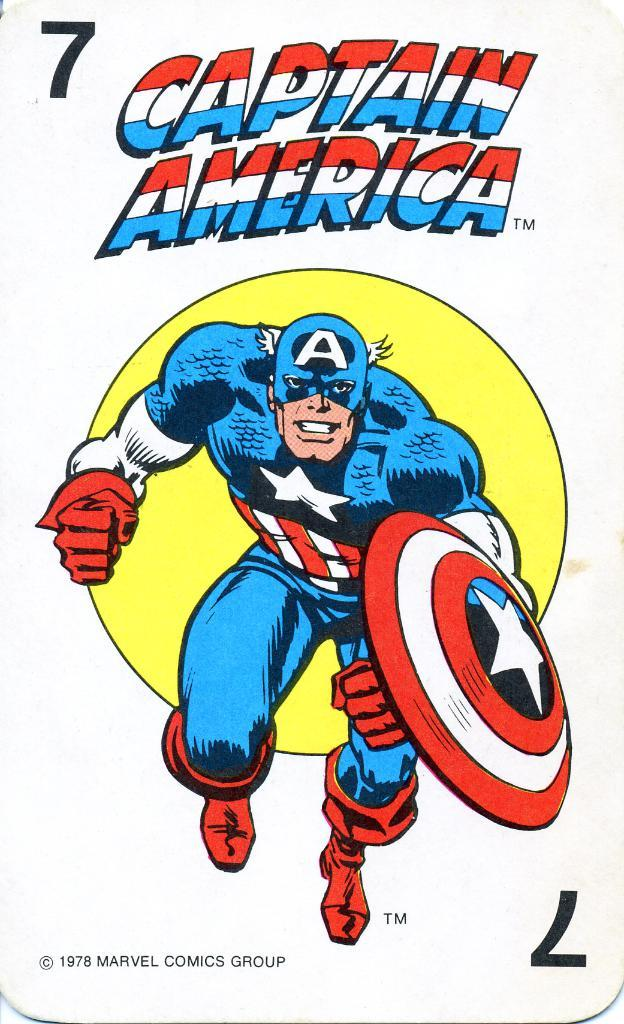What is the main subject of the image? There is a picture in the image. What can be seen in the picture? The picture contains a man. What is written on the picture? The words "CAPTAIN AMERICA" are printed on the picture. What type of cake is being served in the image? There is no cake present in the image; it features a picture with the words "CAPTAIN AMERICA." What kind of produce is visible in the image? There is no produce visible in the image; it features a picture with the words "CAPTAIN AMERICA." 